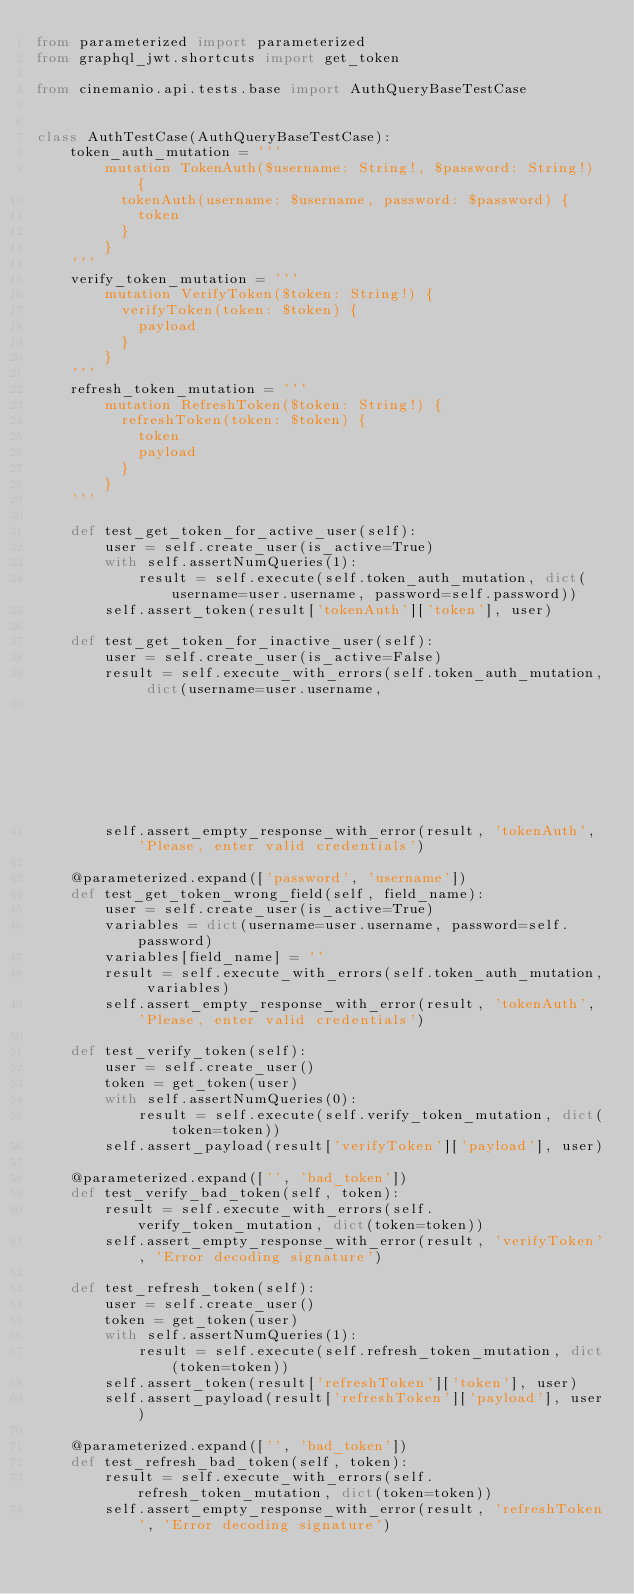Convert code to text. <code><loc_0><loc_0><loc_500><loc_500><_Python_>from parameterized import parameterized
from graphql_jwt.shortcuts import get_token

from cinemanio.api.tests.base import AuthQueryBaseTestCase


class AuthTestCase(AuthQueryBaseTestCase):
    token_auth_mutation = '''
        mutation TokenAuth($username: String!, $password: String!) {
          tokenAuth(username: $username, password: $password) {
            token
          }
        }
    '''
    verify_token_mutation = '''
        mutation VerifyToken($token: String!) {
          verifyToken(token: $token) {
            payload
          }
        }
    '''
    refresh_token_mutation = '''
        mutation RefreshToken($token: String!) {
          refreshToken(token: $token) {
            token
            payload
          }
        }
    '''

    def test_get_token_for_active_user(self):
        user = self.create_user(is_active=True)
        with self.assertNumQueries(1):
            result = self.execute(self.token_auth_mutation, dict(username=user.username, password=self.password))
        self.assert_token(result['tokenAuth']['token'], user)

    def test_get_token_for_inactive_user(self):
        user = self.create_user(is_active=False)
        result = self.execute_with_errors(self.token_auth_mutation, dict(username=user.username,
                                                                         password=self.password))
        self.assert_empty_response_with_error(result, 'tokenAuth', 'Please, enter valid credentials')

    @parameterized.expand(['password', 'username'])
    def test_get_token_wrong_field(self, field_name):
        user = self.create_user(is_active=True)
        variables = dict(username=user.username, password=self.password)
        variables[field_name] = ''
        result = self.execute_with_errors(self.token_auth_mutation, variables)
        self.assert_empty_response_with_error(result, 'tokenAuth', 'Please, enter valid credentials')

    def test_verify_token(self):
        user = self.create_user()
        token = get_token(user)
        with self.assertNumQueries(0):
            result = self.execute(self.verify_token_mutation, dict(token=token))
        self.assert_payload(result['verifyToken']['payload'], user)

    @parameterized.expand(['', 'bad_token'])
    def test_verify_bad_token(self, token):
        result = self.execute_with_errors(self.verify_token_mutation, dict(token=token))
        self.assert_empty_response_with_error(result, 'verifyToken', 'Error decoding signature')

    def test_refresh_token(self):
        user = self.create_user()
        token = get_token(user)
        with self.assertNumQueries(1):
            result = self.execute(self.refresh_token_mutation, dict(token=token))
        self.assert_token(result['refreshToken']['token'], user)
        self.assert_payload(result['refreshToken']['payload'], user)

    @parameterized.expand(['', 'bad_token'])
    def test_refresh_bad_token(self, token):
        result = self.execute_with_errors(self.refresh_token_mutation, dict(token=token))
        self.assert_empty_response_with_error(result, 'refreshToken', 'Error decoding signature')
</code> 